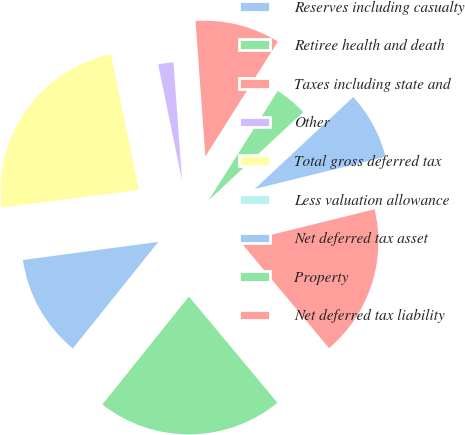<chart> <loc_0><loc_0><loc_500><loc_500><pie_chart><fcel>Reserves including casualty<fcel>Retiree health and death<fcel>Taxes including state and<fcel>Other<fcel>Total gross deferred tax<fcel>Less valuation allowance<fcel>Net deferred tax asset<fcel>Property<fcel>Net deferred tax liability<nl><fcel>8.11%<fcel>4.08%<fcel>10.12%<fcel>2.07%<fcel>23.83%<fcel>0.06%<fcel>12.13%<fcel>21.82%<fcel>17.79%<nl></chart> 